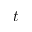<formula> <loc_0><loc_0><loc_500><loc_500>t</formula> 